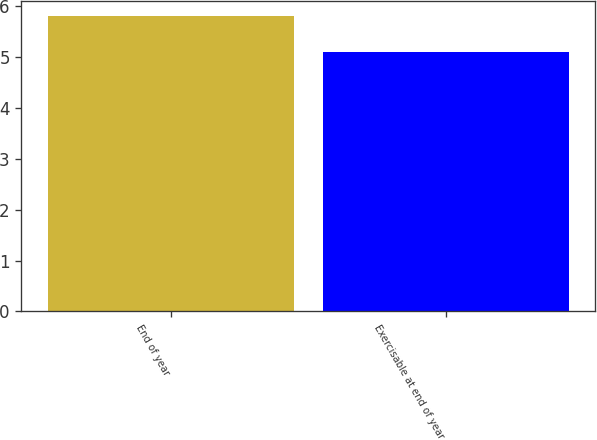Convert chart. <chart><loc_0><loc_0><loc_500><loc_500><bar_chart><fcel>End of year<fcel>Exercisable at end of year<nl><fcel>5.8<fcel>5.1<nl></chart> 